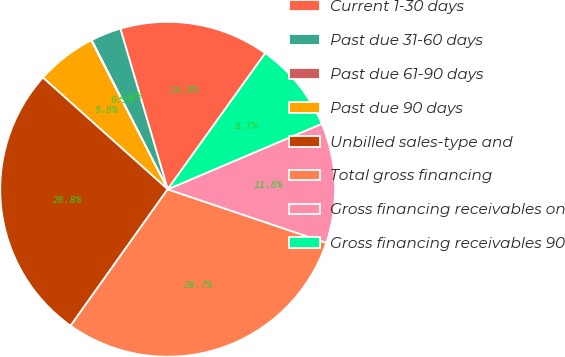Convert chart to OTSL. <chart><loc_0><loc_0><loc_500><loc_500><pie_chart><fcel>Current 1-30 days<fcel>Past due 31-60 days<fcel>Past due 61-90 days<fcel>Past due 90 days<fcel>Unbilled sales-type and<fcel>Total gross financing<fcel>Gross financing receivables on<fcel>Gross financing receivables 90<nl><fcel>14.46%<fcel>2.94%<fcel>0.06%<fcel>5.82%<fcel>26.78%<fcel>29.66%<fcel>11.58%<fcel>8.7%<nl></chart> 